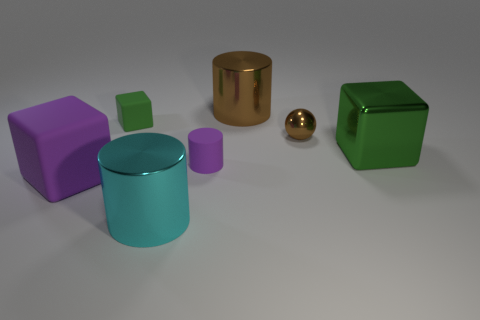Is the number of purple blocks that are in front of the small purple object the same as the number of small brown balls?
Make the answer very short. Yes. How many other things are there of the same shape as the big purple rubber thing?
Ensure brevity in your answer.  2. The big purple object has what shape?
Provide a succinct answer. Cube. Are the purple cylinder and the tiny cube made of the same material?
Provide a succinct answer. Yes. Are there the same number of big cyan metal things that are behind the large rubber thing and brown metallic balls behind the big green thing?
Offer a very short reply. No. Is there a big cyan metal object right of the shiny cylinder to the right of the big cyan metal object that is on the left side of the tiny shiny ball?
Your response must be concise. No. Do the metallic block and the brown cylinder have the same size?
Give a very brief answer. Yes. What is the color of the matte cube in front of the purple rubber thing on the right side of the green thing behind the large green block?
Keep it short and to the point. Purple. How many things are the same color as the shiny block?
Offer a terse response. 1. How many large things are either red rubber things or purple objects?
Give a very brief answer. 1. 